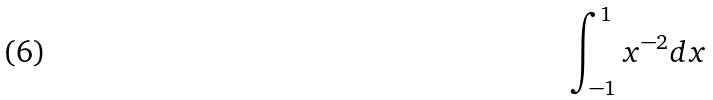Convert formula to latex. <formula><loc_0><loc_0><loc_500><loc_500>\int _ { - 1 } ^ { 1 } x ^ { - 2 } d x</formula> 